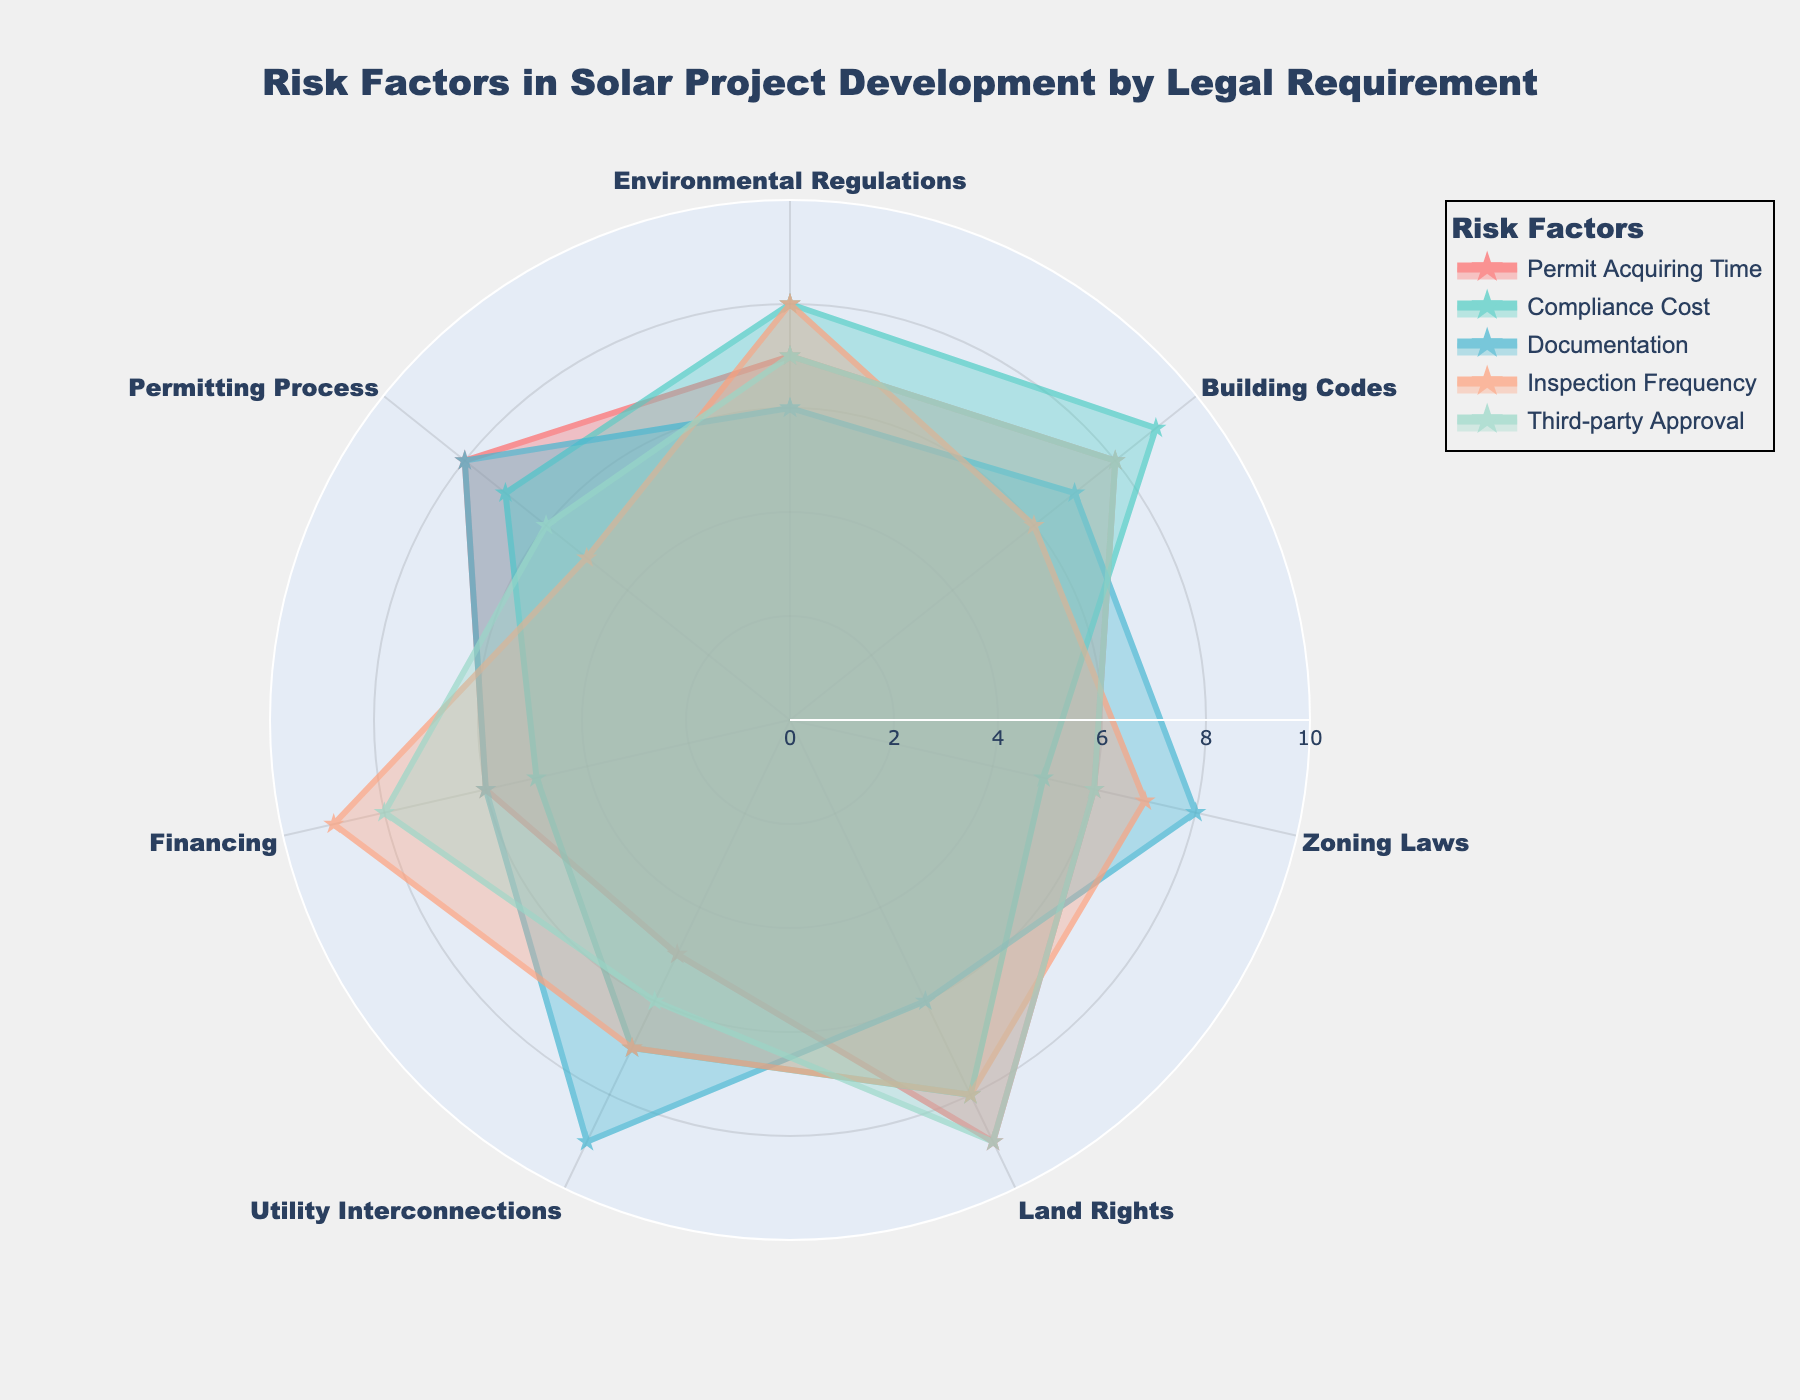what is the title of the figure? The title is written at the top of the figure in bold font. It describes what the radar chart is about.
Answer: Risk Factors in Solar Project Development by Legal Requirement Which legal requirement has the highest value for Third-party Approval? By looking at the section for Third-party Approval and observing the highest spike, you can see which legal requirement it aligns with.
Answer: Land Rights What is the average value for Compliance Cost? The Compliance Cost section includes 7 data points. Summing them up (8 + 9 + 5 + 8 + 7 + 5 + 7 = 49) and dividing by the number of points (7) gives the average.
Answer: 7 Which requirement has the lowest value in Permitting Process? Looking at the values marked under Permitting Process and identifying the lowest one among the 7 requirements, you can determine the answer.
Answer: Utility Interconnections Is the Inspection Frequency higher for Zoning Laws or Building Codes? By comparing the spikes corresponding to Zoning Laws and Building Codes under the Inspection Frequency section, you can tell which is higher.
Answer: Zoning Laws Which factor has the most uniform distribution of values across Legal Requirements? By visually inspecting the shapes formed by the data points for each factor and seeing which one has the most similar values across all legal requirements, you can identify the answer.
Answer: Documentation How many categories are there on the radar chart? Counting the sectors marked on the radar chart gives you the number of categories.
Answer: 6 What is the difference in Compliance Cost between Building Codes and Zoning Laws? First, locate the Compliance Cost values for both Building Codes (9) and Zoning Laws (5). Subtract the Zoning Laws value from the Building Codes value (9 - 5 = 4).
Answer: 4 Which legal requirement has the most variation in values across all factors? By observing the spread of values for each legal requirement and identifying which has the widest range, you find the one with the most variation.
Answer: Building Codes What is the combined value of Inspection Frequency for Utility Interconnections and Financing? Adding the Inspection Frequency values for Utility Interconnections (7) and Financing (9) gives the combined value (7 + 9 = 16).
Answer: 16 